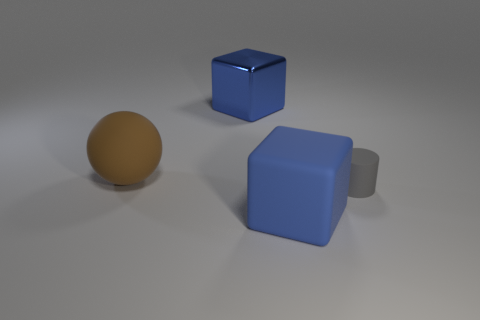Add 1 tiny blue metallic cylinders. How many objects exist? 5 Subtract all balls. How many objects are left? 3 Add 4 blue matte things. How many blue matte things are left? 5 Add 2 large cubes. How many large cubes exist? 4 Subtract 0 yellow cylinders. How many objects are left? 4 Subtract all small gray things. Subtract all gray matte cylinders. How many objects are left? 2 